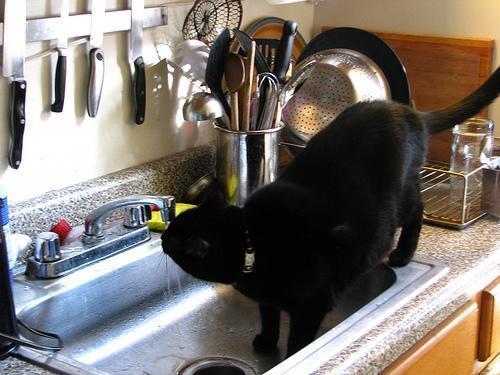How many cats are there?
Give a very brief answer. 1. 